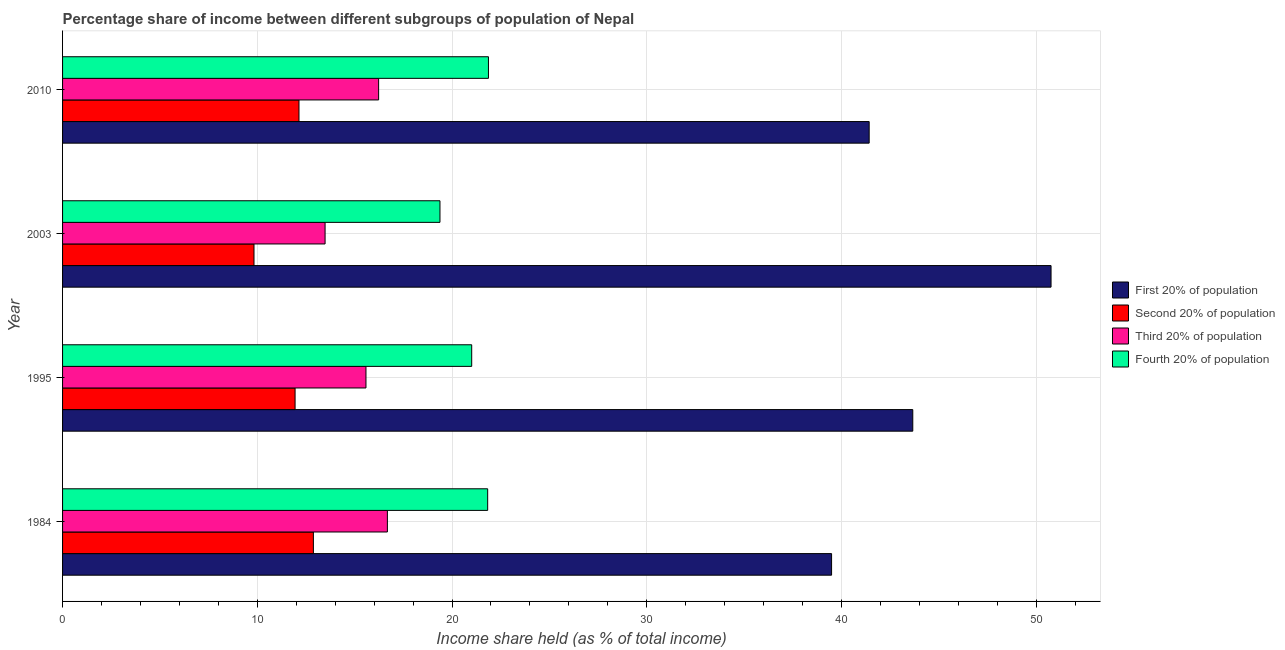How many groups of bars are there?
Give a very brief answer. 4. How many bars are there on the 3rd tick from the top?
Offer a very short reply. 4. In how many cases, is the number of bars for a given year not equal to the number of legend labels?
Your answer should be very brief. 0. What is the share of the income held by fourth 20% of the population in 2010?
Keep it short and to the point. 21.87. Across all years, what is the maximum share of the income held by first 20% of the population?
Your answer should be compact. 50.76. Across all years, what is the minimum share of the income held by second 20% of the population?
Keep it short and to the point. 9.83. What is the total share of the income held by second 20% of the population in the graph?
Offer a very short reply. 46.79. What is the difference between the share of the income held by first 20% of the population in 1984 and that in 2003?
Your answer should be compact. -11.27. What is the difference between the share of the income held by third 20% of the population in 2010 and the share of the income held by fourth 20% of the population in 2003?
Offer a very short reply. -3.15. What is the average share of the income held by fourth 20% of the population per year?
Your answer should be compact. 21.02. In the year 1984, what is the difference between the share of the income held by first 20% of the population and share of the income held by third 20% of the population?
Offer a terse response. 22.81. In how many years, is the share of the income held by first 20% of the population greater than 50 %?
Offer a terse response. 1. What is the ratio of the share of the income held by second 20% of the population in 1995 to that in 2010?
Make the answer very short. 0.98. What is the difference between the highest and the second highest share of the income held by first 20% of the population?
Your response must be concise. 7.1. What is the difference between the highest and the lowest share of the income held by first 20% of the population?
Your answer should be compact. 11.27. Is the sum of the share of the income held by third 20% of the population in 1984 and 2010 greater than the maximum share of the income held by first 20% of the population across all years?
Your answer should be compact. No. Is it the case that in every year, the sum of the share of the income held by first 20% of the population and share of the income held by third 20% of the population is greater than the sum of share of the income held by second 20% of the population and share of the income held by fourth 20% of the population?
Your answer should be compact. Yes. What does the 3rd bar from the top in 1995 represents?
Your response must be concise. Second 20% of population. What does the 2nd bar from the bottom in 1984 represents?
Offer a terse response. Second 20% of population. Are all the bars in the graph horizontal?
Offer a very short reply. Yes. What is the difference between two consecutive major ticks on the X-axis?
Keep it short and to the point. 10. Are the values on the major ticks of X-axis written in scientific E-notation?
Your response must be concise. No. Where does the legend appear in the graph?
Your answer should be very brief. Center right. What is the title of the graph?
Provide a short and direct response. Percentage share of income between different subgroups of population of Nepal. What is the label or title of the X-axis?
Provide a short and direct response. Income share held (as % of total income). What is the Income share held (as % of total income) of First 20% of population in 1984?
Offer a very short reply. 39.49. What is the Income share held (as % of total income) of Second 20% of population in 1984?
Offer a terse response. 12.88. What is the Income share held (as % of total income) in Third 20% of population in 1984?
Your answer should be compact. 16.68. What is the Income share held (as % of total income) in Fourth 20% of population in 1984?
Offer a terse response. 21.83. What is the Income share held (as % of total income) in First 20% of population in 1995?
Keep it short and to the point. 43.66. What is the Income share held (as % of total income) of Second 20% of population in 1995?
Offer a terse response. 11.94. What is the Income share held (as % of total income) of Third 20% of population in 1995?
Keep it short and to the point. 15.58. What is the Income share held (as % of total income) in Fourth 20% of population in 1995?
Your answer should be very brief. 21.01. What is the Income share held (as % of total income) of First 20% of population in 2003?
Keep it short and to the point. 50.76. What is the Income share held (as % of total income) in Second 20% of population in 2003?
Provide a short and direct response. 9.83. What is the Income share held (as % of total income) in Third 20% of population in 2003?
Offer a very short reply. 13.48. What is the Income share held (as % of total income) in Fourth 20% of population in 2003?
Provide a short and direct response. 19.38. What is the Income share held (as % of total income) of First 20% of population in 2010?
Your response must be concise. 41.42. What is the Income share held (as % of total income) in Second 20% of population in 2010?
Offer a terse response. 12.14. What is the Income share held (as % of total income) of Third 20% of population in 2010?
Provide a short and direct response. 16.23. What is the Income share held (as % of total income) of Fourth 20% of population in 2010?
Provide a short and direct response. 21.87. Across all years, what is the maximum Income share held (as % of total income) in First 20% of population?
Give a very brief answer. 50.76. Across all years, what is the maximum Income share held (as % of total income) of Second 20% of population?
Offer a terse response. 12.88. Across all years, what is the maximum Income share held (as % of total income) in Third 20% of population?
Offer a terse response. 16.68. Across all years, what is the maximum Income share held (as % of total income) of Fourth 20% of population?
Provide a succinct answer. 21.87. Across all years, what is the minimum Income share held (as % of total income) in First 20% of population?
Your answer should be very brief. 39.49. Across all years, what is the minimum Income share held (as % of total income) in Second 20% of population?
Offer a very short reply. 9.83. Across all years, what is the minimum Income share held (as % of total income) in Third 20% of population?
Your answer should be very brief. 13.48. Across all years, what is the minimum Income share held (as % of total income) in Fourth 20% of population?
Your answer should be very brief. 19.38. What is the total Income share held (as % of total income) in First 20% of population in the graph?
Offer a very short reply. 175.33. What is the total Income share held (as % of total income) in Second 20% of population in the graph?
Provide a succinct answer. 46.79. What is the total Income share held (as % of total income) of Third 20% of population in the graph?
Offer a very short reply. 61.97. What is the total Income share held (as % of total income) of Fourth 20% of population in the graph?
Keep it short and to the point. 84.09. What is the difference between the Income share held (as % of total income) of First 20% of population in 1984 and that in 1995?
Your answer should be very brief. -4.17. What is the difference between the Income share held (as % of total income) of Second 20% of population in 1984 and that in 1995?
Offer a terse response. 0.94. What is the difference between the Income share held (as % of total income) of Third 20% of population in 1984 and that in 1995?
Provide a short and direct response. 1.1. What is the difference between the Income share held (as % of total income) in Fourth 20% of population in 1984 and that in 1995?
Ensure brevity in your answer.  0.82. What is the difference between the Income share held (as % of total income) of First 20% of population in 1984 and that in 2003?
Your answer should be compact. -11.27. What is the difference between the Income share held (as % of total income) of Second 20% of population in 1984 and that in 2003?
Your answer should be compact. 3.05. What is the difference between the Income share held (as % of total income) of Fourth 20% of population in 1984 and that in 2003?
Ensure brevity in your answer.  2.45. What is the difference between the Income share held (as % of total income) in First 20% of population in 1984 and that in 2010?
Your response must be concise. -1.93. What is the difference between the Income share held (as % of total income) in Second 20% of population in 1984 and that in 2010?
Your answer should be very brief. 0.74. What is the difference between the Income share held (as % of total income) in Third 20% of population in 1984 and that in 2010?
Ensure brevity in your answer.  0.45. What is the difference between the Income share held (as % of total income) of Fourth 20% of population in 1984 and that in 2010?
Offer a very short reply. -0.04. What is the difference between the Income share held (as % of total income) in First 20% of population in 1995 and that in 2003?
Offer a terse response. -7.1. What is the difference between the Income share held (as % of total income) in Second 20% of population in 1995 and that in 2003?
Ensure brevity in your answer.  2.11. What is the difference between the Income share held (as % of total income) of Fourth 20% of population in 1995 and that in 2003?
Keep it short and to the point. 1.63. What is the difference between the Income share held (as % of total income) in First 20% of population in 1995 and that in 2010?
Your response must be concise. 2.24. What is the difference between the Income share held (as % of total income) in Third 20% of population in 1995 and that in 2010?
Keep it short and to the point. -0.65. What is the difference between the Income share held (as % of total income) of Fourth 20% of population in 1995 and that in 2010?
Your answer should be very brief. -0.86. What is the difference between the Income share held (as % of total income) in First 20% of population in 2003 and that in 2010?
Ensure brevity in your answer.  9.34. What is the difference between the Income share held (as % of total income) in Second 20% of population in 2003 and that in 2010?
Make the answer very short. -2.31. What is the difference between the Income share held (as % of total income) in Third 20% of population in 2003 and that in 2010?
Your response must be concise. -2.75. What is the difference between the Income share held (as % of total income) in Fourth 20% of population in 2003 and that in 2010?
Ensure brevity in your answer.  -2.49. What is the difference between the Income share held (as % of total income) of First 20% of population in 1984 and the Income share held (as % of total income) of Second 20% of population in 1995?
Keep it short and to the point. 27.55. What is the difference between the Income share held (as % of total income) of First 20% of population in 1984 and the Income share held (as % of total income) of Third 20% of population in 1995?
Give a very brief answer. 23.91. What is the difference between the Income share held (as % of total income) of First 20% of population in 1984 and the Income share held (as % of total income) of Fourth 20% of population in 1995?
Give a very brief answer. 18.48. What is the difference between the Income share held (as % of total income) of Second 20% of population in 1984 and the Income share held (as % of total income) of Third 20% of population in 1995?
Ensure brevity in your answer.  -2.7. What is the difference between the Income share held (as % of total income) of Second 20% of population in 1984 and the Income share held (as % of total income) of Fourth 20% of population in 1995?
Offer a very short reply. -8.13. What is the difference between the Income share held (as % of total income) of Third 20% of population in 1984 and the Income share held (as % of total income) of Fourth 20% of population in 1995?
Provide a short and direct response. -4.33. What is the difference between the Income share held (as % of total income) in First 20% of population in 1984 and the Income share held (as % of total income) in Second 20% of population in 2003?
Ensure brevity in your answer.  29.66. What is the difference between the Income share held (as % of total income) in First 20% of population in 1984 and the Income share held (as % of total income) in Third 20% of population in 2003?
Offer a terse response. 26.01. What is the difference between the Income share held (as % of total income) of First 20% of population in 1984 and the Income share held (as % of total income) of Fourth 20% of population in 2003?
Give a very brief answer. 20.11. What is the difference between the Income share held (as % of total income) of Second 20% of population in 1984 and the Income share held (as % of total income) of Third 20% of population in 2003?
Make the answer very short. -0.6. What is the difference between the Income share held (as % of total income) in First 20% of population in 1984 and the Income share held (as % of total income) in Second 20% of population in 2010?
Give a very brief answer. 27.35. What is the difference between the Income share held (as % of total income) of First 20% of population in 1984 and the Income share held (as % of total income) of Third 20% of population in 2010?
Offer a terse response. 23.26. What is the difference between the Income share held (as % of total income) in First 20% of population in 1984 and the Income share held (as % of total income) in Fourth 20% of population in 2010?
Provide a short and direct response. 17.62. What is the difference between the Income share held (as % of total income) in Second 20% of population in 1984 and the Income share held (as % of total income) in Third 20% of population in 2010?
Make the answer very short. -3.35. What is the difference between the Income share held (as % of total income) of Second 20% of population in 1984 and the Income share held (as % of total income) of Fourth 20% of population in 2010?
Keep it short and to the point. -8.99. What is the difference between the Income share held (as % of total income) in Third 20% of population in 1984 and the Income share held (as % of total income) in Fourth 20% of population in 2010?
Your response must be concise. -5.19. What is the difference between the Income share held (as % of total income) of First 20% of population in 1995 and the Income share held (as % of total income) of Second 20% of population in 2003?
Ensure brevity in your answer.  33.83. What is the difference between the Income share held (as % of total income) in First 20% of population in 1995 and the Income share held (as % of total income) in Third 20% of population in 2003?
Keep it short and to the point. 30.18. What is the difference between the Income share held (as % of total income) of First 20% of population in 1995 and the Income share held (as % of total income) of Fourth 20% of population in 2003?
Offer a terse response. 24.28. What is the difference between the Income share held (as % of total income) of Second 20% of population in 1995 and the Income share held (as % of total income) of Third 20% of population in 2003?
Ensure brevity in your answer.  -1.54. What is the difference between the Income share held (as % of total income) in Second 20% of population in 1995 and the Income share held (as % of total income) in Fourth 20% of population in 2003?
Make the answer very short. -7.44. What is the difference between the Income share held (as % of total income) of Third 20% of population in 1995 and the Income share held (as % of total income) of Fourth 20% of population in 2003?
Your response must be concise. -3.8. What is the difference between the Income share held (as % of total income) in First 20% of population in 1995 and the Income share held (as % of total income) in Second 20% of population in 2010?
Ensure brevity in your answer.  31.52. What is the difference between the Income share held (as % of total income) in First 20% of population in 1995 and the Income share held (as % of total income) in Third 20% of population in 2010?
Offer a terse response. 27.43. What is the difference between the Income share held (as % of total income) in First 20% of population in 1995 and the Income share held (as % of total income) in Fourth 20% of population in 2010?
Make the answer very short. 21.79. What is the difference between the Income share held (as % of total income) in Second 20% of population in 1995 and the Income share held (as % of total income) in Third 20% of population in 2010?
Give a very brief answer. -4.29. What is the difference between the Income share held (as % of total income) in Second 20% of population in 1995 and the Income share held (as % of total income) in Fourth 20% of population in 2010?
Offer a terse response. -9.93. What is the difference between the Income share held (as % of total income) of Third 20% of population in 1995 and the Income share held (as % of total income) of Fourth 20% of population in 2010?
Your answer should be very brief. -6.29. What is the difference between the Income share held (as % of total income) of First 20% of population in 2003 and the Income share held (as % of total income) of Second 20% of population in 2010?
Your answer should be compact. 38.62. What is the difference between the Income share held (as % of total income) in First 20% of population in 2003 and the Income share held (as % of total income) in Third 20% of population in 2010?
Provide a succinct answer. 34.53. What is the difference between the Income share held (as % of total income) in First 20% of population in 2003 and the Income share held (as % of total income) in Fourth 20% of population in 2010?
Offer a very short reply. 28.89. What is the difference between the Income share held (as % of total income) in Second 20% of population in 2003 and the Income share held (as % of total income) in Fourth 20% of population in 2010?
Your answer should be compact. -12.04. What is the difference between the Income share held (as % of total income) in Third 20% of population in 2003 and the Income share held (as % of total income) in Fourth 20% of population in 2010?
Ensure brevity in your answer.  -8.39. What is the average Income share held (as % of total income) of First 20% of population per year?
Offer a terse response. 43.83. What is the average Income share held (as % of total income) of Second 20% of population per year?
Provide a short and direct response. 11.7. What is the average Income share held (as % of total income) of Third 20% of population per year?
Your answer should be compact. 15.49. What is the average Income share held (as % of total income) in Fourth 20% of population per year?
Offer a very short reply. 21.02. In the year 1984, what is the difference between the Income share held (as % of total income) in First 20% of population and Income share held (as % of total income) in Second 20% of population?
Keep it short and to the point. 26.61. In the year 1984, what is the difference between the Income share held (as % of total income) in First 20% of population and Income share held (as % of total income) in Third 20% of population?
Your answer should be compact. 22.81. In the year 1984, what is the difference between the Income share held (as % of total income) in First 20% of population and Income share held (as % of total income) in Fourth 20% of population?
Offer a very short reply. 17.66. In the year 1984, what is the difference between the Income share held (as % of total income) in Second 20% of population and Income share held (as % of total income) in Fourth 20% of population?
Provide a succinct answer. -8.95. In the year 1984, what is the difference between the Income share held (as % of total income) in Third 20% of population and Income share held (as % of total income) in Fourth 20% of population?
Your answer should be compact. -5.15. In the year 1995, what is the difference between the Income share held (as % of total income) in First 20% of population and Income share held (as % of total income) in Second 20% of population?
Your answer should be compact. 31.72. In the year 1995, what is the difference between the Income share held (as % of total income) of First 20% of population and Income share held (as % of total income) of Third 20% of population?
Offer a very short reply. 28.08. In the year 1995, what is the difference between the Income share held (as % of total income) of First 20% of population and Income share held (as % of total income) of Fourth 20% of population?
Offer a very short reply. 22.65. In the year 1995, what is the difference between the Income share held (as % of total income) of Second 20% of population and Income share held (as % of total income) of Third 20% of population?
Your response must be concise. -3.64. In the year 1995, what is the difference between the Income share held (as % of total income) in Second 20% of population and Income share held (as % of total income) in Fourth 20% of population?
Provide a short and direct response. -9.07. In the year 1995, what is the difference between the Income share held (as % of total income) in Third 20% of population and Income share held (as % of total income) in Fourth 20% of population?
Offer a terse response. -5.43. In the year 2003, what is the difference between the Income share held (as % of total income) of First 20% of population and Income share held (as % of total income) of Second 20% of population?
Your answer should be compact. 40.93. In the year 2003, what is the difference between the Income share held (as % of total income) of First 20% of population and Income share held (as % of total income) of Third 20% of population?
Offer a terse response. 37.28. In the year 2003, what is the difference between the Income share held (as % of total income) of First 20% of population and Income share held (as % of total income) of Fourth 20% of population?
Ensure brevity in your answer.  31.38. In the year 2003, what is the difference between the Income share held (as % of total income) of Second 20% of population and Income share held (as % of total income) of Third 20% of population?
Your response must be concise. -3.65. In the year 2003, what is the difference between the Income share held (as % of total income) of Second 20% of population and Income share held (as % of total income) of Fourth 20% of population?
Make the answer very short. -9.55. In the year 2003, what is the difference between the Income share held (as % of total income) in Third 20% of population and Income share held (as % of total income) in Fourth 20% of population?
Your answer should be compact. -5.9. In the year 2010, what is the difference between the Income share held (as % of total income) in First 20% of population and Income share held (as % of total income) in Second 20% of population?
Your answer should be compact. 29.28. In the year 2010, what is the difference between the Income share held (as % of total income) of First 20% of population and Income share held (as % of total income) of Third 20% of population?
Offer a very short reply. 25.19. In the year 2010, what is the difference between the Income share held (as % of total income) in First 20% of population and Income share held (as % of total income) in Fourth 20% of population?
Give a very brief answer. 19.55. In the year 2010, what is the difference between the Income share held (as % of total income) in Second 20% of population and Income share held (as % of total income) in Third 20% of population?
Give a very brief answer. -4.09. In the year 2010, what is the difference between the Income share held (as % of total income) in Second 20% of population and Income share held (as % of total income) in Fourth 20% of population?
Provide a succinct answer. -9.73. In the year 2010, what is the difference between the Income share held (as % of total income) of Third 20% of population and Income share held (as % of total income) of Fourth 20% of population?
Offer a very short reply. -5.64. What is the ratio of the Income share held (as % of total income) of First 20% of population in 1984 to that in 1995?
Provide a succinct answer. 0.9. What is the ratio of the Income share held (as % of total income) in Second 20% of population in 1984 to that in 1995?
Keep it short and to the point. 1.08. What is the ratio of the Income share held (as % of total income) of Third 20% of population in 1984 to that in 1995?
Offer a very short reply. 1.07. What is the ratio of the Income share held (as % of total income) in Fourth 20% of population in 1984 to that in 1995?
Ensure brevity in your answer.  1.04. What is the ratio of the Income share held (as % of total income) of First 20% of population in 1984 to that in 2003?
Provide a succinct answer. 0.78. What is the ratio of the Income share held (as % of total income) in Second 20% of population in 1984 to that in 2003?
Ensure brevity in your answer.  1.31. What is the ratio of the Income share held (as % of total income) of Third 20% of population in 1984 to that in 2003?
Your answer should be very brief. 1.24. What is the ratio of the Income share held (as % of total income) of Fourth 20% of population in 1984 to that in 2003?
Provide a succinct answer. 1.13. What is the ratio of the Income share held (as % of total income) of First 20% of population in 1984 to that in 2010?
Keep it short and to the point. 0.95. What is the ratio of the Income share held (as % of total income) of Second 20% of population in 1984 to that in 2010?
Give a very brief answer. 1.06. What is the ratio of the Income share held (as % of total income) in Third 20% of population in 1984 to that in 2010?
Your answer should be compact. 1.03. What is the ratio of the Income share held (as % of total income) in First 20% of population in 1995 to that in 2003?
Give a very brief answer. 0.86. What is the ratio of the Income share held (as % of total income) in Second 20% of population in 1995 to that in 2003?
Give a very brief answer. 1.21. What is the ratio of the Income share held (as % of total income) of Third 20% of population in 1995 to that in 2003?
Keep it short and to the point. 1.16. What is the ratio of the Income share held (as % of total income) in Fourth 20% of population in 1995 to that in 2003?
Offer a very short reply. 1.08. What is the ratio of the Income share held (as % of total income) of First 20% of population in 1995 to that in 2010?
Your answer should be very brief. 1.05. What is the ratio of the Income share held (as % of total income) in Second 20% of population in 1995 to that in 2010?
Ensure brevity in your answer.  0.98. What is the ratio of the Income share held (as % of total income) of Third 20% of population in 1995 to that in 2010?
Your answer should be compact. 0.96. What is the ratio of the Income share held (as % of total income) of Fourth 20% of population in 1995 to that in 2010?
Ensure brevity in your answer.  0.96. What is the ratio of the Income share held (as % of total income) of First 20% of population in 2003 to that in 2010?
Your response must be concise. 1.23. What is the ratio of the Income share held (as % of total income) in Second 20% of population in 2003 to that in 2010?
Provide a short and direct response. 0.81. What is the ratio of the Income share held (as % of total income) of Third 20% of population in 2003 to that in 2010?
Provide a short and direct response. 0.83. What is the ratio of the Income share held (as % of total income) in Fourth 20% of population in 2003 to that in 2010?
Give a very brief answer. 0.89. What is the difference between the highest and the second highest Income share held (as % of total income) of Second 20% of population?
Your answer should be compact. 0.74. What is the difference between the highest and the second highest Income share held (as % of total income) of Third 20% of population?
Your answer should be very brief. 0.45. What is the difference between the highest and the second highest Income share held (as % of total income) in Fourth 20% of population?
Make the answer very short. 0.04. What is the difference between the highest and the lowest Income share held (as % of total income) of First 20% of population?
Offer a very short reply. 11.27. What is the difference between the highest and the lowest Income share held (as % of total income) of Second 20% of population?
Make the answer very short. 3.05. What is the difference between the highest and the lowest Income share held (as % of total income) in Fourth 20% of population?
Your response must be concise. 2.49. 